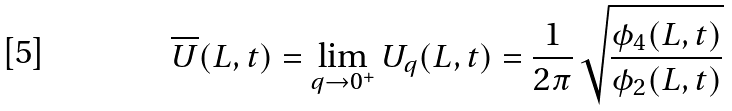Convert formula to latex. <formula><loc_0><loc_0><loc_500><loc_500>\overline { U } ( L , t ) = \lim _ { q \to 0 ^ { + } } U _ { q } ( L , t ) = \frac { 1 } { 2 \pi } \, \sqrt { \frac { \phi _ { 4 } ( L , t ) } { \phi _ { 2 } ( L , t ) } }</formula> 